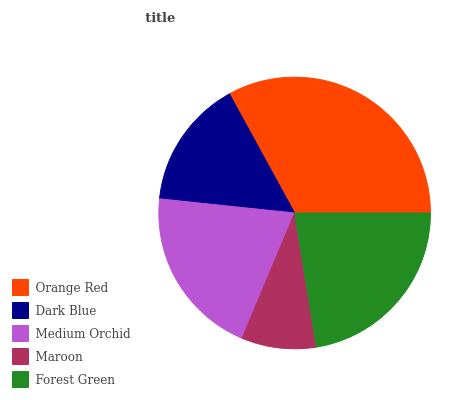Is Maroon the minimum?
Answer yes or no. Yes. Is Orange Red the maximum?
Answer yes or no. Yes. Is Dark Blue the minimum?
Answer yes or no. No. Is Dark Blue the maximum?
Answer yes or no. No. Is Orange Red greater than Dark Blue?
Answer yes or no. Yes. Is Dark Blue less than Orange Red?
Answer yes or no. Yes. Is Dark Blue greater than Orange Red?
Answer yes or no. No. Is Orange Red less than Dark Blue?
Answer yes or no. No. Is Medium Orchid the high median?
Answer yes or no. Yes. Is Medium Orchid the low median?
Answer yes or no. Yes. Is Forest Green the high median?
Answer yes or no. No. Is Orange Red the low median?
Answer yes or no. No. 